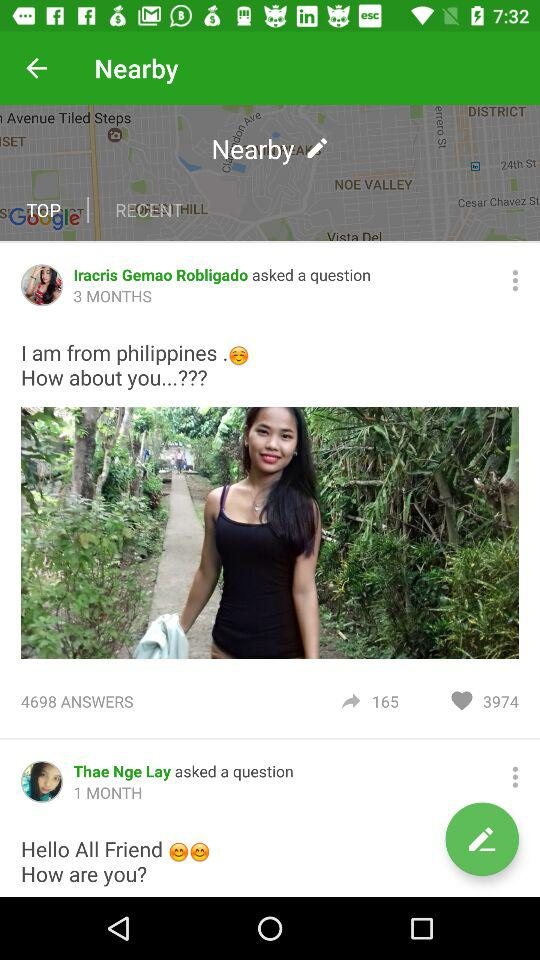Between "TOP" and "RECENT", which option is selected? The selected option is "TOP". 